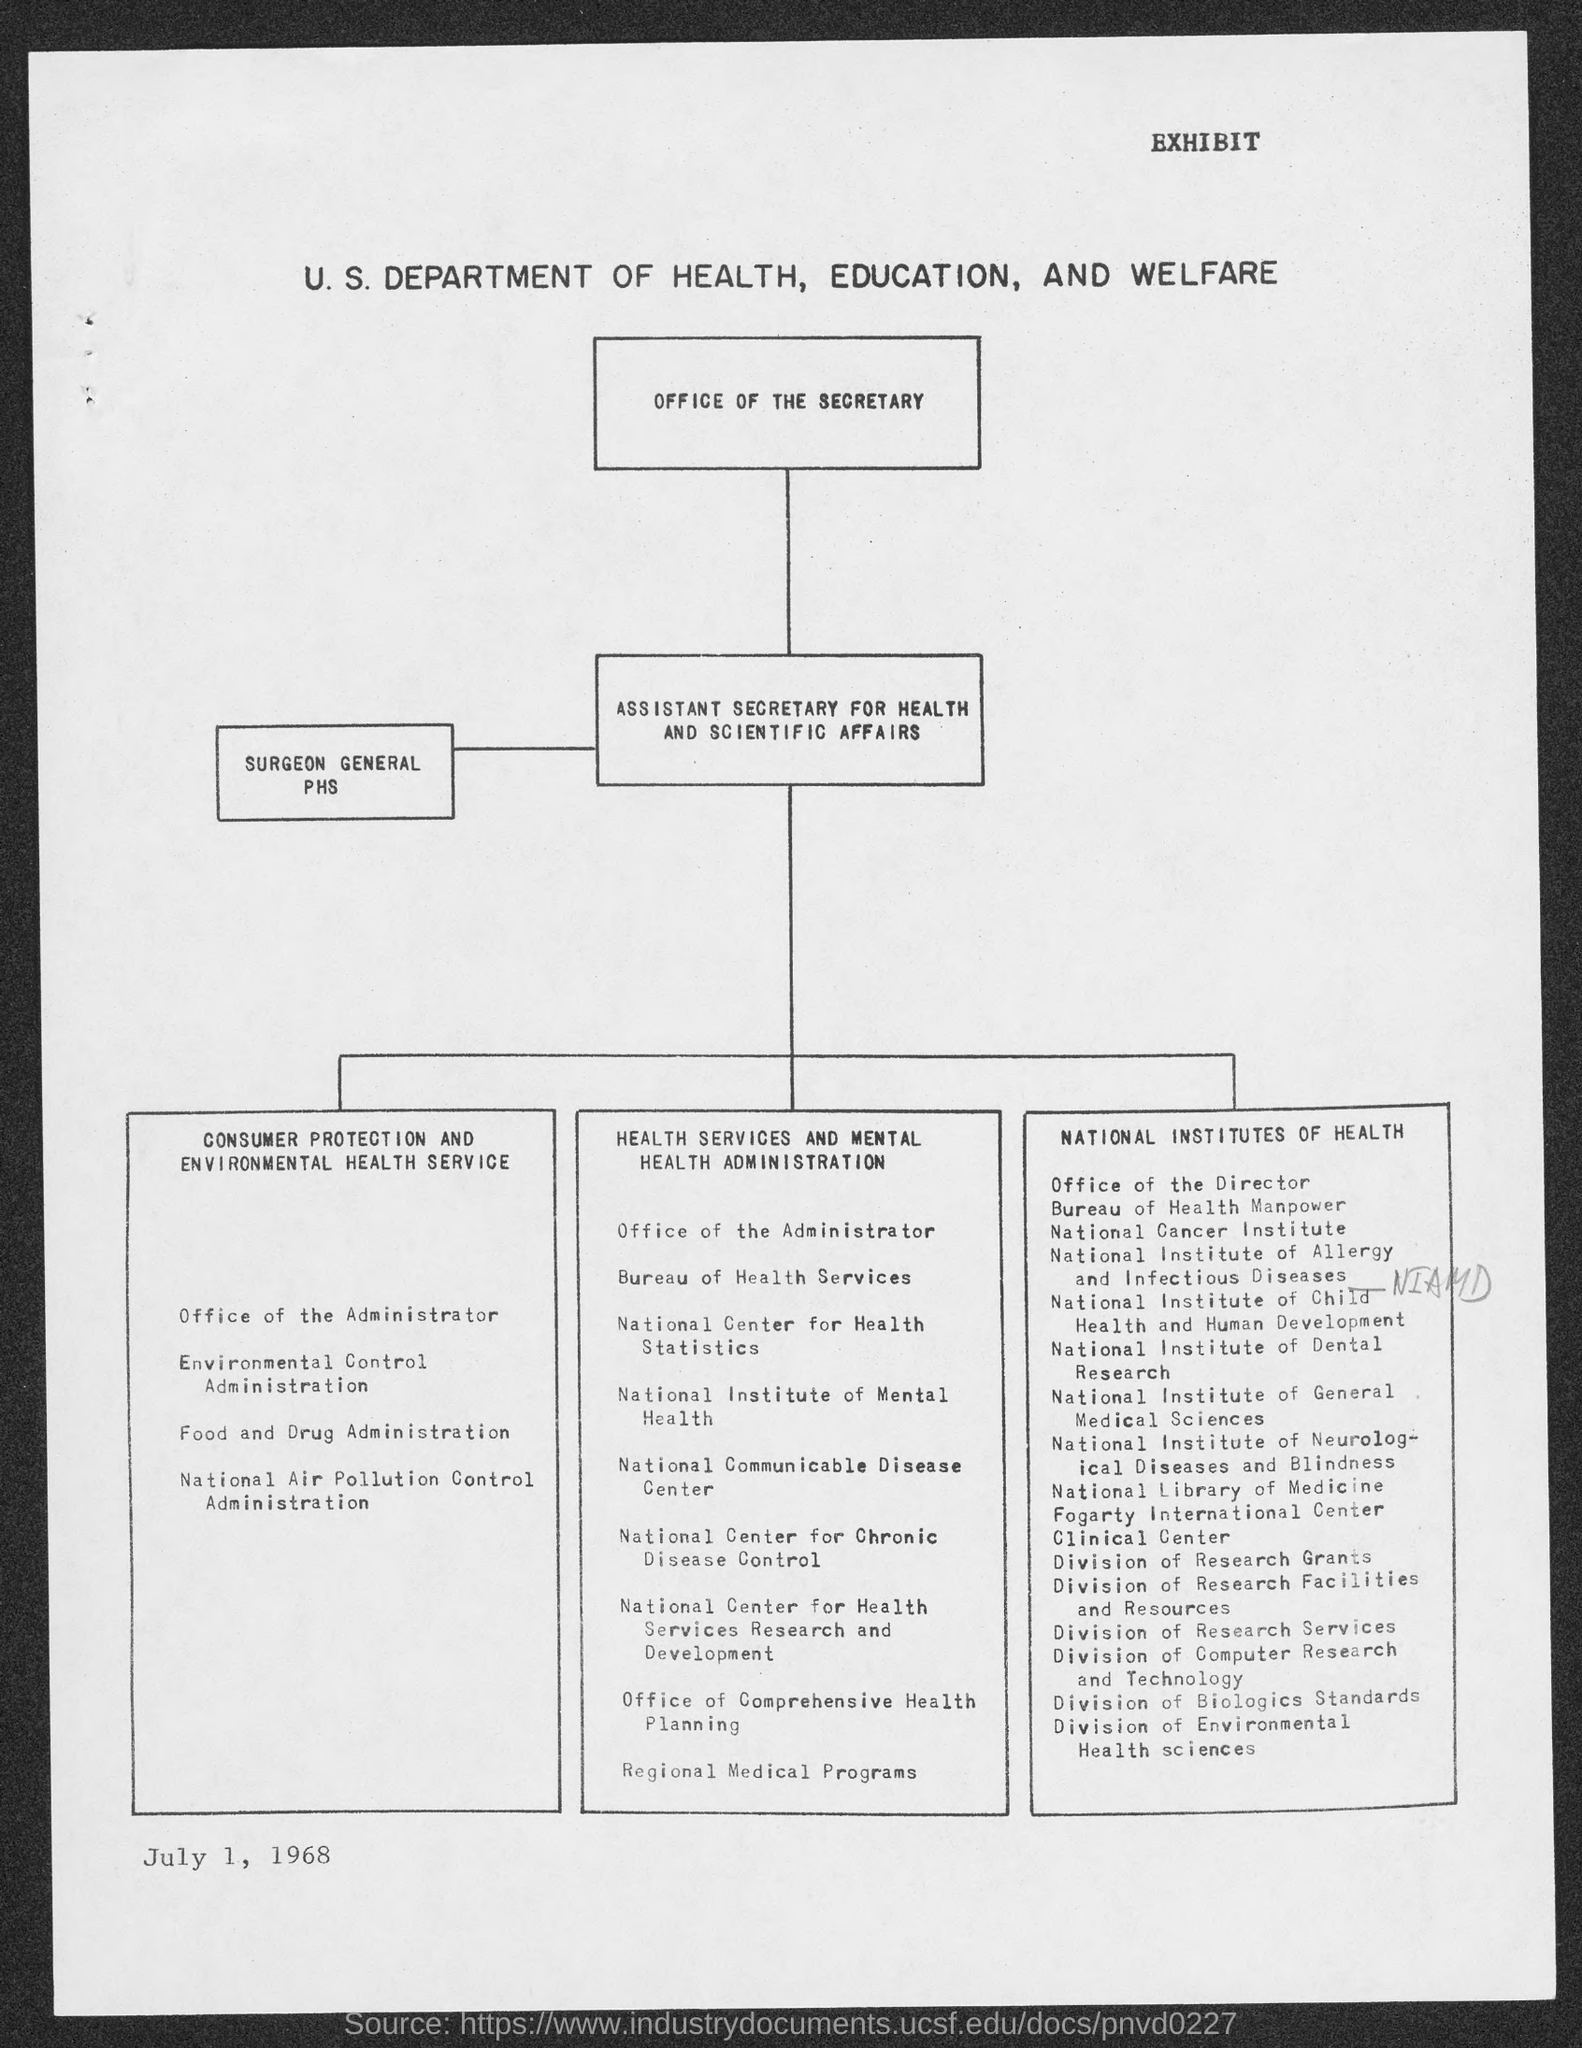Indicate a few pertinent items in this graphic. The document is titled 'EXHIBIT.' The date is July 1, 1968. 